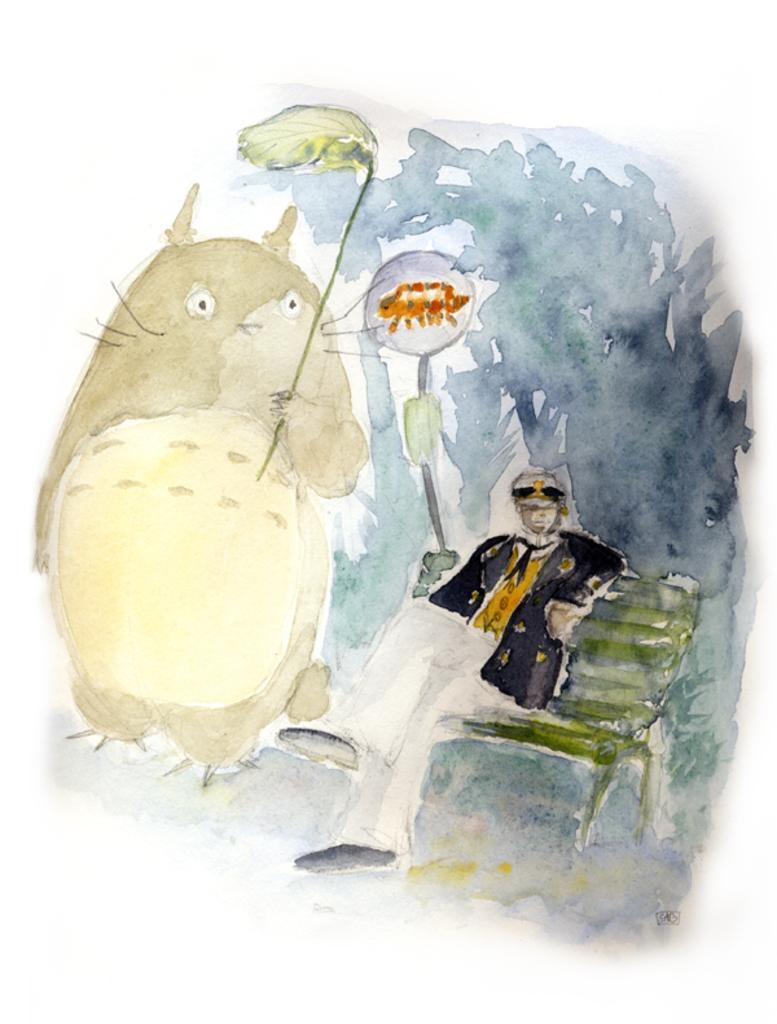Can you describe this image briefly? In this image we can see a painting. In the painting there is a animal holding a leaf in its hand and a person sitting on the bench. 